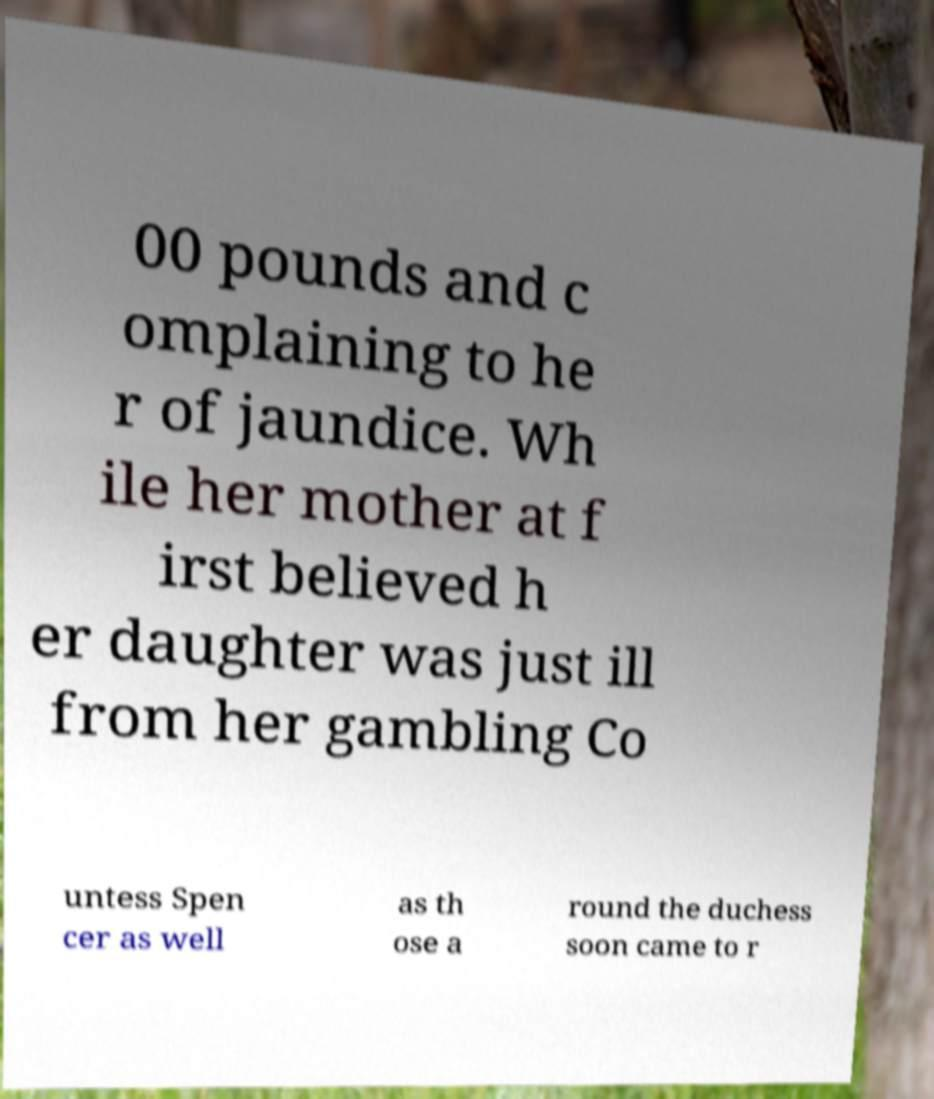Can you accurately transcribe the text from the provided image for me? 00 pounds and c omplaining to he r of jaundice. Wh ile her mother at f irst believed h er daughter was just ill from her gambling Co untess Spen cer as well as th ose a round the duchess soon came to r 